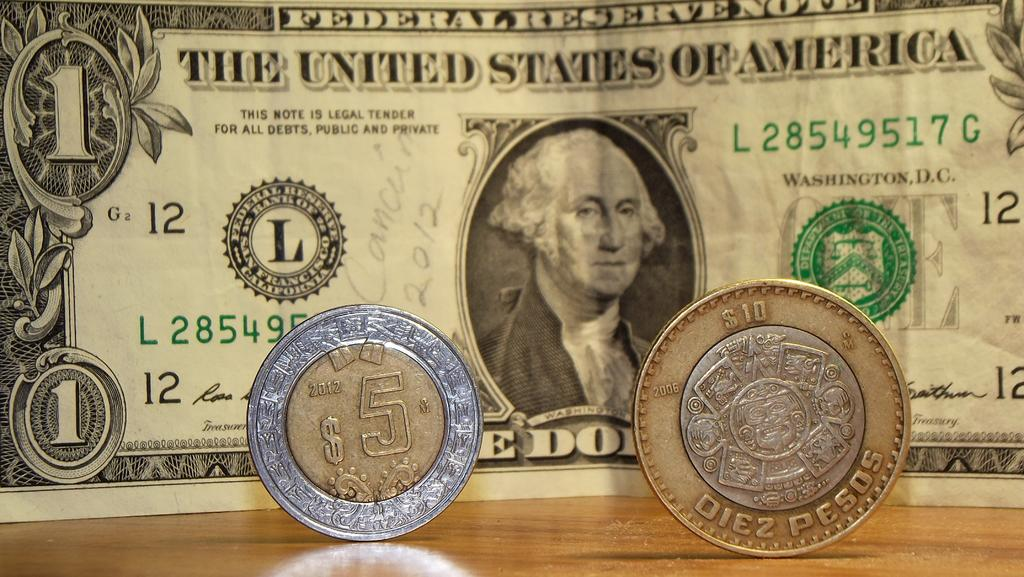<image>
Present a compact description of the photo's key features. 5 and 10 Peso are etched onto these two coins, which sit in front of a dollar bill. 